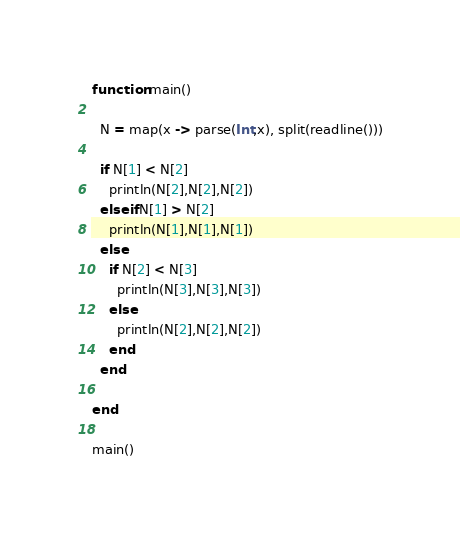Convert code to text. <code><loc_0><loc_0><loc_500><loc_500><_Julia_>function main()
  
  N = map(x -> parse(Int,x), split(readline()))
  
  if N[1] < N[2]
    println(N[2],N[2],N[2])
  elseif N[1] > N[2]
    println(N[1],N[1],N[1])
  else
    if N[2] < N[3]
      println(N[3],N[3],N[3])
    else
      println(N[2],N[2],N[2])
    end
  end
  
end

main()</code> 